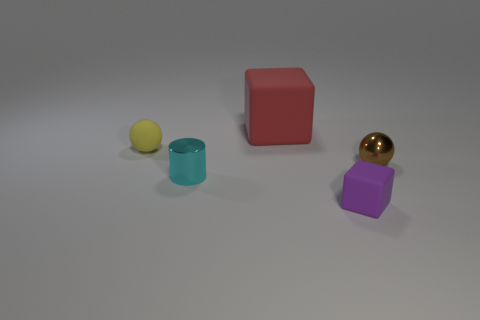Add 1 big gray rubber balls. How many objects exist? 6 Subtract all cubes. How many objects are left? 3 Add 3 tiny yellow rubber cylinders. How many tiny yellow rubber cylinders exist? 3 Subtract 0 blue spheres. How many objects are left? 5 Subtract all tiny cyan metal cylinders. Subtract all red matte things. How many objects are left? 3 Add 3 small cyan objects. How many small cyan objects are left? 4 